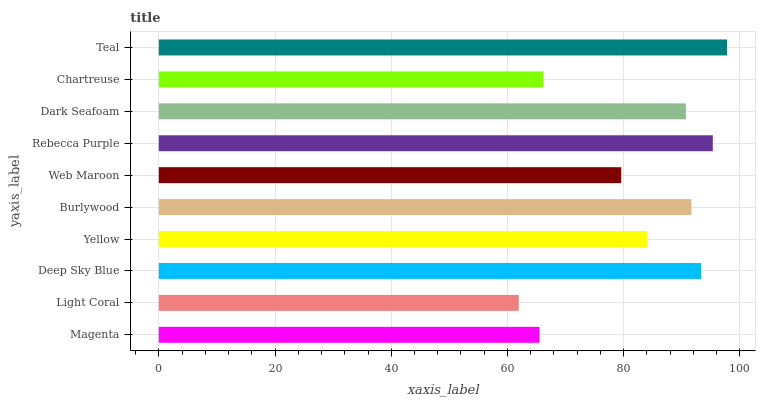Is Light Coral the minimum?
Answer yes or no. Yes. Is Teal the maximum?
Answer yes or no. Yes. Is Deep Sky Blue the minimum?
Answer yes or no. No. Is Deep Sky Blue the maximum?
Answer yes or no. No. Is Deep Sky Blue greater than Light Coral?
Answer yes or no. Yes. Is Light Coral less than Deep Sky Blue?
Answer yes or no. Yes. Is Light Coral greater than Deep Sky Blue?
Answer yes or no. No. Is Deep Sky Blue less than Light Coral?
Answer yes or no. No. Is Dark Seafoam the high median?
Answer yes or no. Yes. Is Yellow the low median?
Answer yes or no. Yes. Is Light Coral the high median?
Answer yes or no. No. Is Chartreuse the low median?
Answer yes or no. No. 